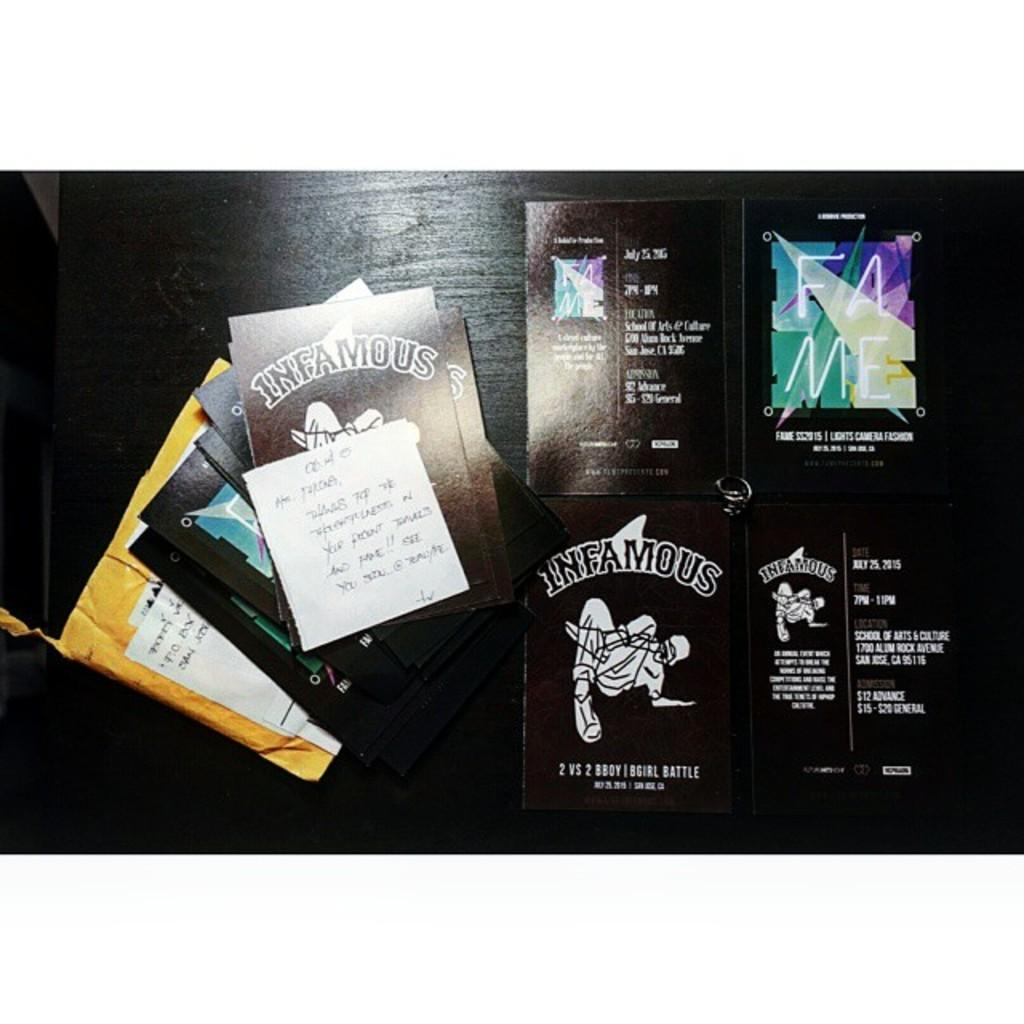<image>
Create a compact narrative representing the image presented. the word infamous is on a black surface 